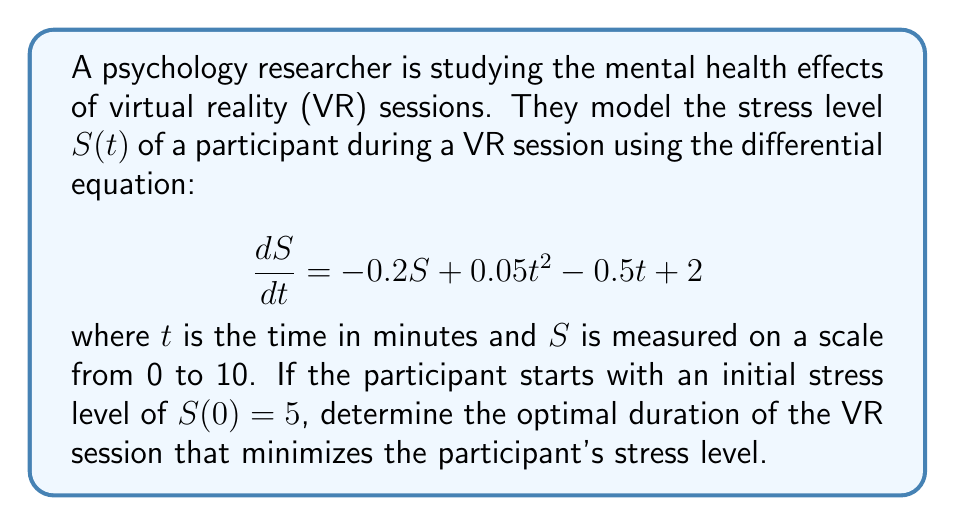Can you answer this question? To solve this problem, we need to follow these steps:

1) First, we need to solve the given differential equation:

   $$\frac{dS}{dt} = -0.2S + 0.05t^2 - 0.5t + 2$$

   This is a first-order linear differential equation.

2) The general solution to this equation is:

   $$S(t) = e^{-0.2t}(C + \int (0.05t^2 - 0.5t + 2)e^{0.2t} dt)$$

   where $C$ is a constant of integration.

3) After integrating and simplifying, we get:

   $$S(t) = 10 + \frac{5t^2}{4} - \frac{5t}{2} + Ce^{-0.2t}$$

4) Using the initial condition $S(0) = 5$, we can find $C$:

   $$5 = 10 + C \implies C = -5$$

5) Therefore, the particular solution is:

   $$S(t) = 10 + \frac{5t^2}{4} - \frac{5t}{2} - 5e^{-0.2t}$$

6) To find the minimum stress level, we need to find where $\frac{dS}{dt} = 0$:

   $$\frac{dS}{dt} = \frac{5t}{2} - \frac{5}{2} + e^{-0.2t} = 0$$

7) This equation can't be solved analytically, so we need to use numerical methods. Using a graphing calculator or computer software, we can find that this equation is satisfied when $t \approx 5.67$ minutes.

8) To confirm this is a minimum, we can check the second derivative is positive at this point.

Therefore, the optimal duration of the VR session that minimizes the participant's stress level is approximately 5.67 minutes.
Answer: The optimal duration of the VR session is approximately 5.67 minutes. 